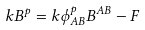<formula> <loc_0><loc_0><loc_500><loc_500>k B ^ { p } = k \phi ^ { p } _ { A B } B ^ { A B } - F</formula> 